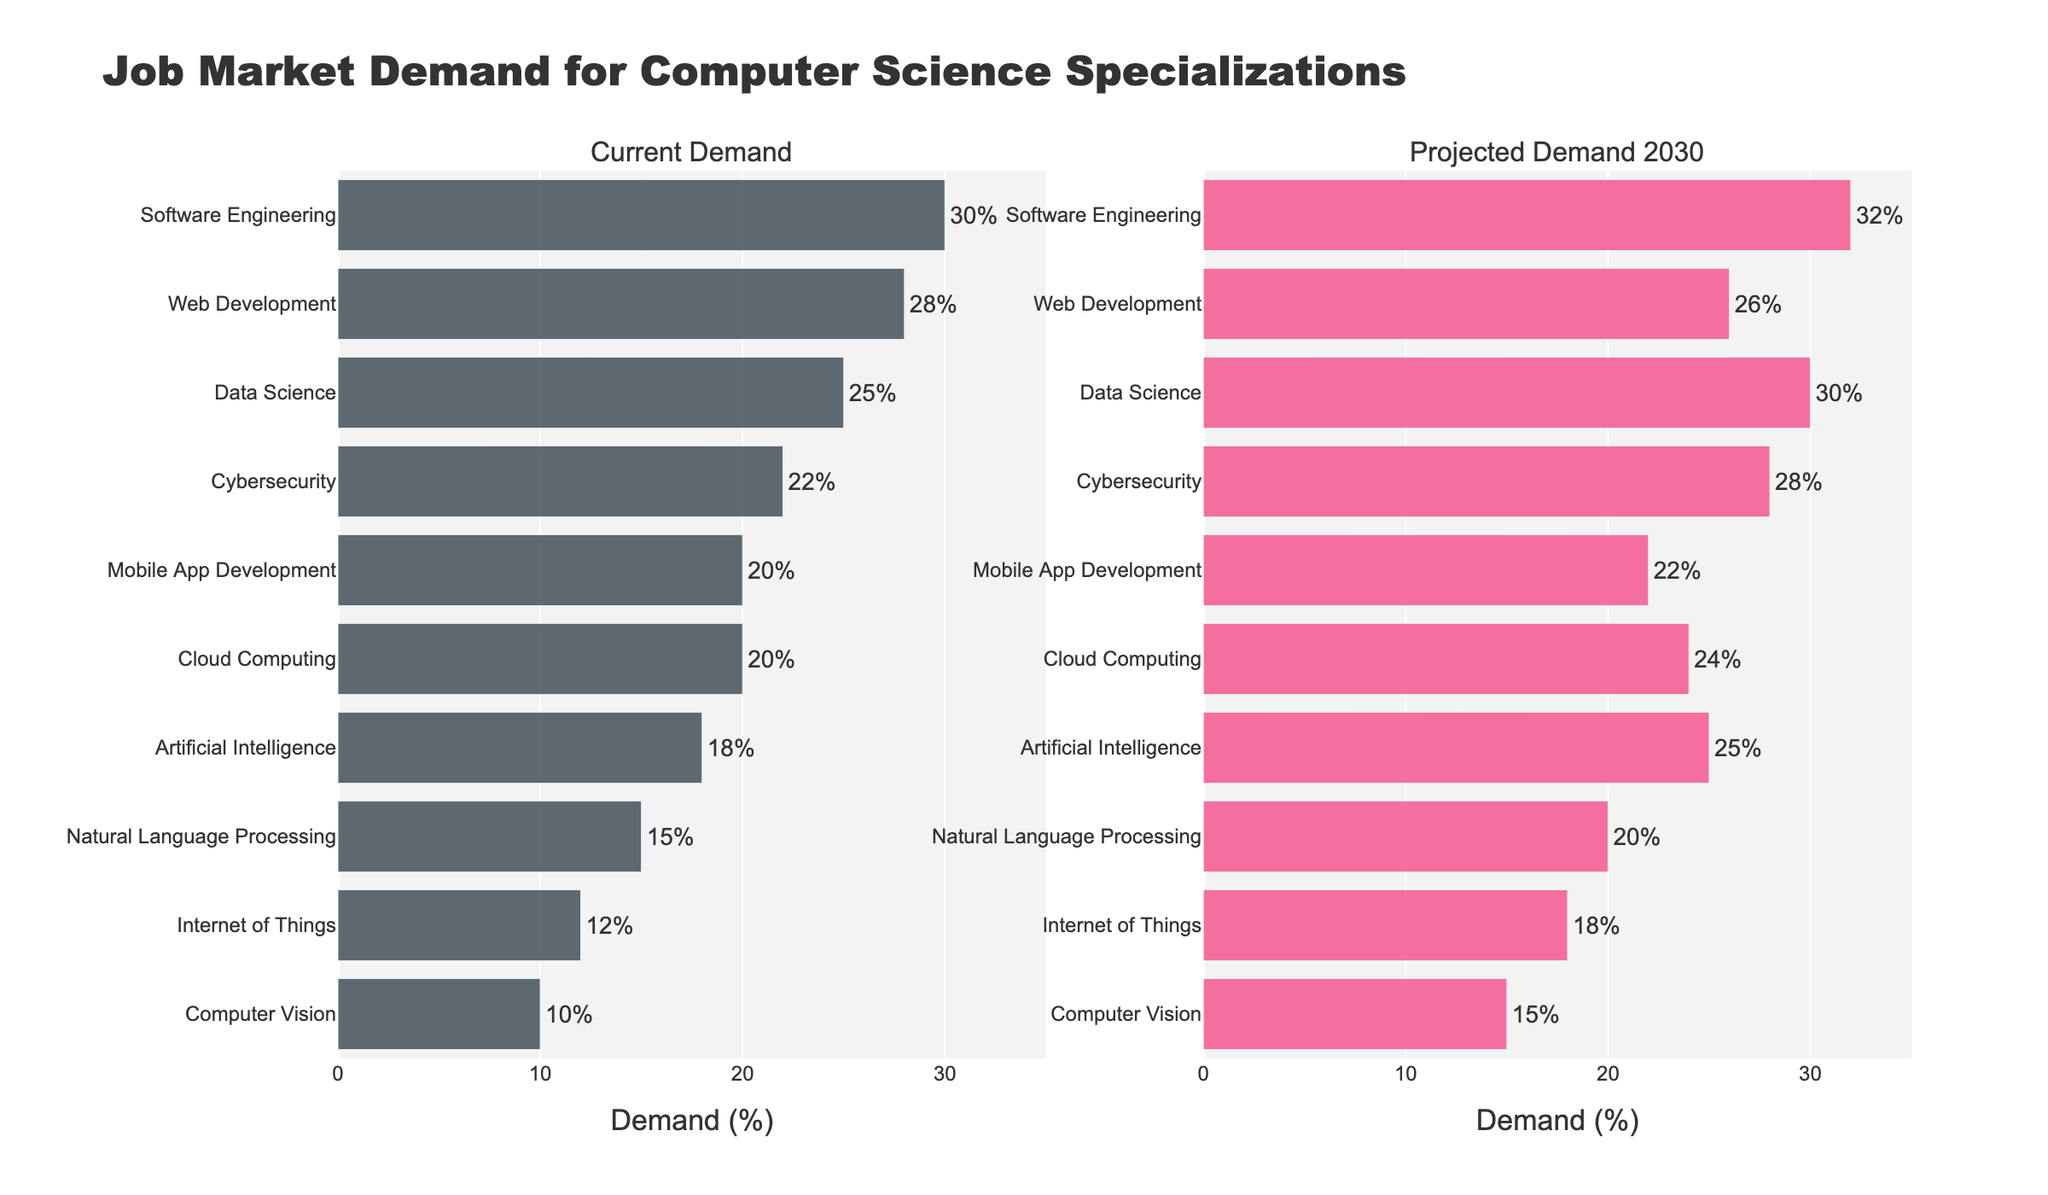Which specialization has the highest current demand? Look at the "Current Demand" subplot and identify the specialization with the bar extending furthest to the right.
Answer: Software Engineering What is the projected demand for Artificial Intelligence in 2030? Refer to the "Projected Demand 2030" subplot and locate the bar corresponding to Artificial Intelligence.
Answer: 25% How much is the demand for Data Science expected to increase by 2030? Find the difference between the projected demand and the current demand for Data Science by subtracting the current demand percentage from the projected demand percentage.
Answer: 5% Which specialization shows a decrease in demand from the current to projected future? Compare the lengths of the bars for each specialization in both the current and projected subplots, and identify the one where the projected bar is shorter.
Answer: Web Development What visual elements are used to display the demand percentages clearly? Observe the figure to identify elements such as colored bars, percentage text labels outside the bars, and subplot titles.
Answer: Colored bars, percentage labels, subplot titles Which specialization has the smallest current demand, and what is that percentage? Look at the "Current Demand" subplot and identify the shortest bar and its corresponding percentage.
Answer: Computer Vision, 10% What is the difference in projected demand between Cybersecurity and Internet of Things in 2030? Subtract the projected demand percentage of Internet of Things from that of Cybersecurity.
Answer: 10% How do the demands for Web Development change from the current to 2030? Compare the lengths of the Web Development bars in both subplots to see the change in percentage.
Answer: Decreases from 28% to 26% What is the combined percentage of current demand for Cybersecurity and Cloud Computing? Add the current demand percentages of Cybersecurity and Cloud Computing.
Answer: 42% Which specialization has the highest projected demand in 2030, and what is that percentage? Look at the "Projected Demand 2030" subplot and identify the specialization with the bar extending furthest to the right, noting the percentage.
Answer: Data Science, 30% 